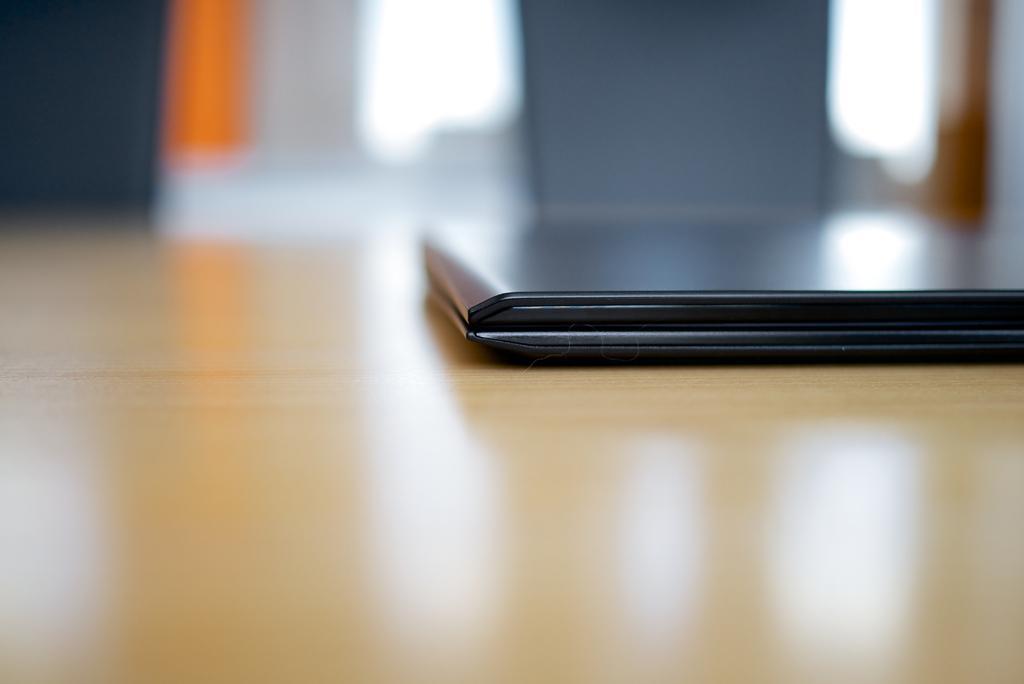Can you describe this image briefly? This image is taken indoors. In this image the background is a little blurred. At the bottom of the image there is a table. On the right side of the image there is a laptop on the table. 